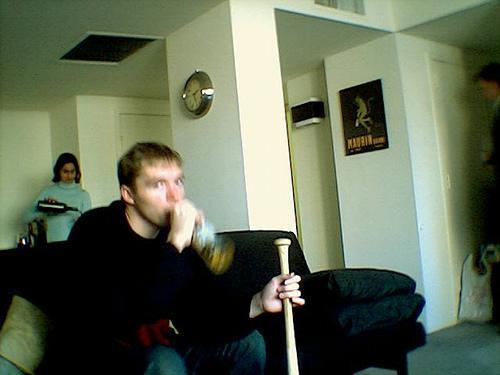How many kinds of alcohol are in this photo?
Give a very brief answer. 2. How many people are there?
Give a very brief answer. 2. 